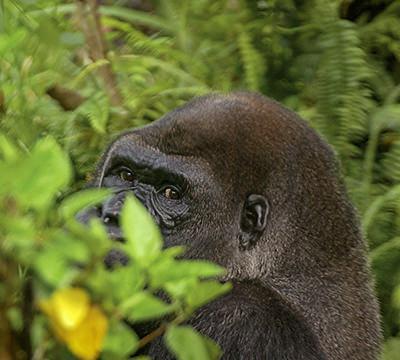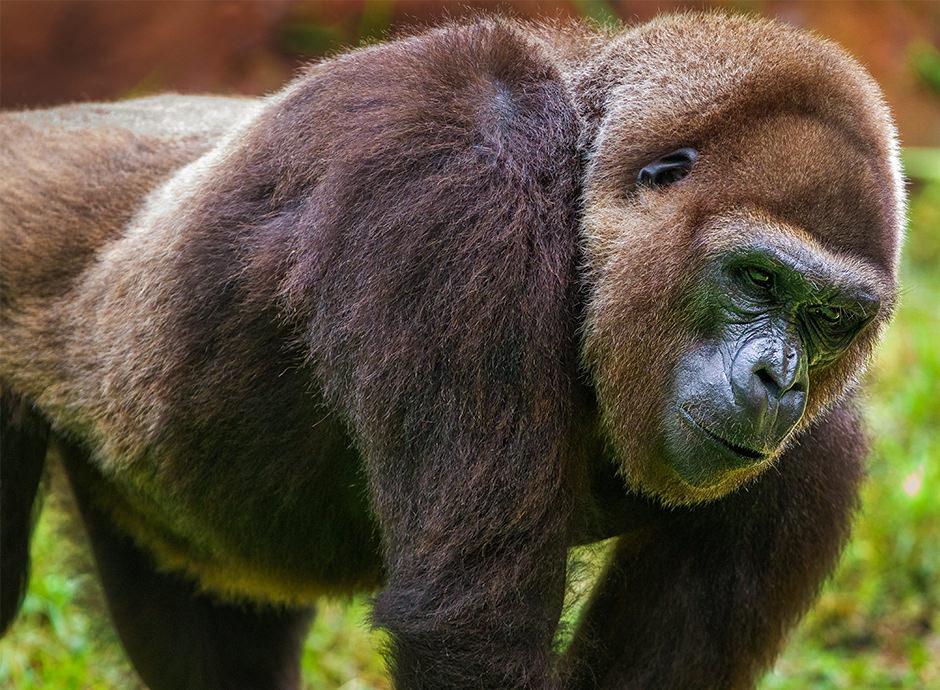The first image is the image on the left, the second image is the image on the right. Analyze the images presented: Is the assertion "The right image contains one gorilla standing upright on two legs." valid? Answer yes or no. No. The first image is the image on the left, the second image is the image on the right. Evaluate the accuracy of this statement regarding the images: "An ape is standing on two legs.". Is it true? Answer yes or no. No. 